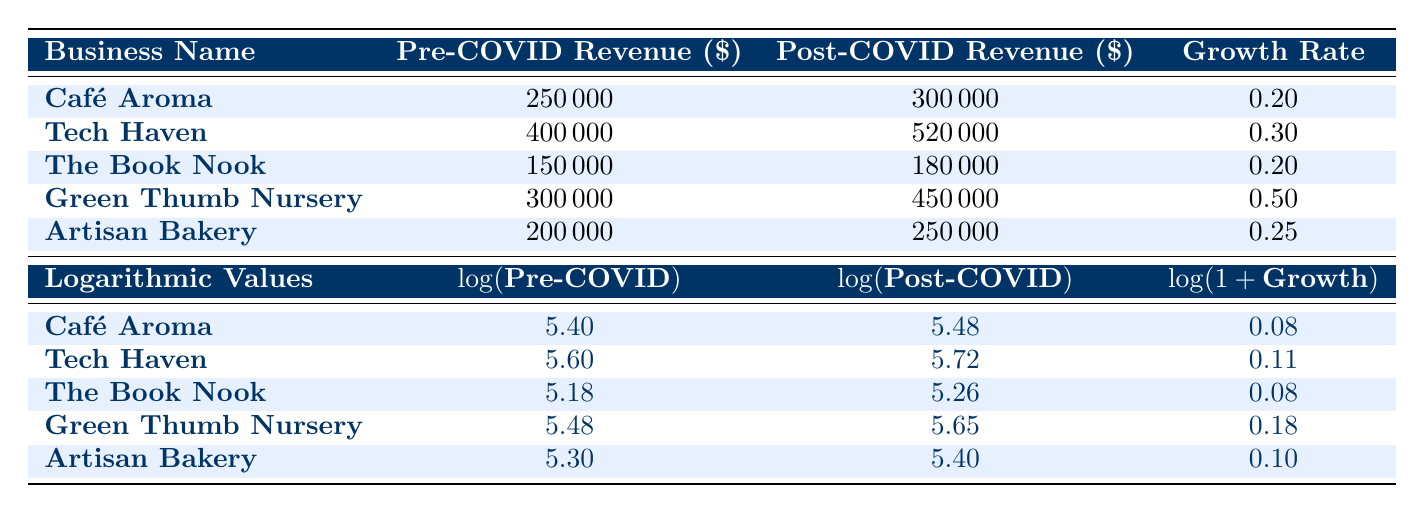What is the growth rate of Green Thumb Nursery? The growth rate for Green Thumb Nursery is provided directly in the table under the growth rate column, which shows a growth rate of 0.50.
Answer: 0.50 What was the post-COVID revenue for Café Aroma? The post-COVID revenue for Café Aroma is clearly listed in the table under the post-COVID revenue column, amounting to $300,000.
Answer: 300000 Which small business had the highest pre-COVID revenue? Looking through the pre-COVID revenue values, Tech Haven has the highest pre-COVID revenue of $400,000 when compared to others.
Answer: Tech Haven Is the growth rate for Artisan Bakery greater than 0.30? The growth rate for Artisan Bakery is listed in the table as 0.25, which is less than 0.30, making the statement false.
Answer: No What is the average growth rate of all the small businesses listed? To find the average growth rate, sum the growth rates: (0.20 + 0.30 + 0.20 + 0.50 + 0.25) = 1.45. Since there are 5 businesses, divide by 5, giving an average of 1.45/5 = 0.29.
Answer: 0.29 Which business has the largest increase in revenue in absolute terms? To determine which business had the largest increase, calculate the absolute revenue increase for each: Café Aroma ($50,000), Tech Haven ($120,000), The Book Nook ($30,000), Green Thumb Nursery ($150,000), Artisan Bakery ($50,000). Green Thumb Nursery shows the largest increase of $150,000.
Answer: Green Thumb Nursery Has the growth rate for any business reached or exceeded 0.25? By reviewing the growth rates, Green Thumb Nursery (0.50), Tech Haven (0.30), and Artisan Bakery (0.25) all have growth rates that meet or exceed 0.25, confirming that at least one business meets the criterion.
Answer: Yes What is the difference in logarithmic values of the post-COVID revenue between Tech Haven and The Book Nook? The logarithmic values of post-COVID revenue for Tech Haven and The Book Nook are 5.72 and 5.26, respectively. The difference is 5.72 - 5.26 = 0.46.
Answer: 0.46 Identify a business that experienced a growth rate less than the average growth rate. The average growth rate calculated previously is 0.29. Both Café Aroma (0.20) and The Book Nook (0.20) have growth rates below this average.
Answer: Café Aroma or The Book Nook 